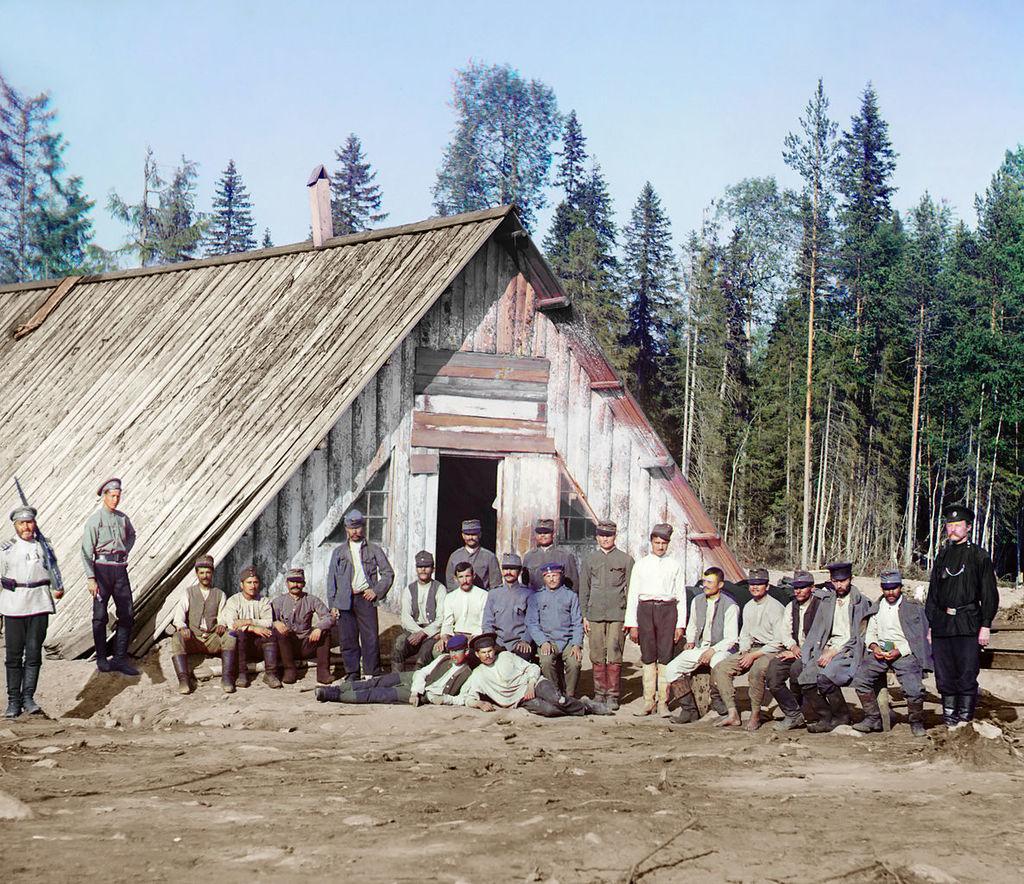Can you describe this image briefly? In the center of the image there is a shed and we can see people sitting and some of them are standing. In the background there are trees and sky. 